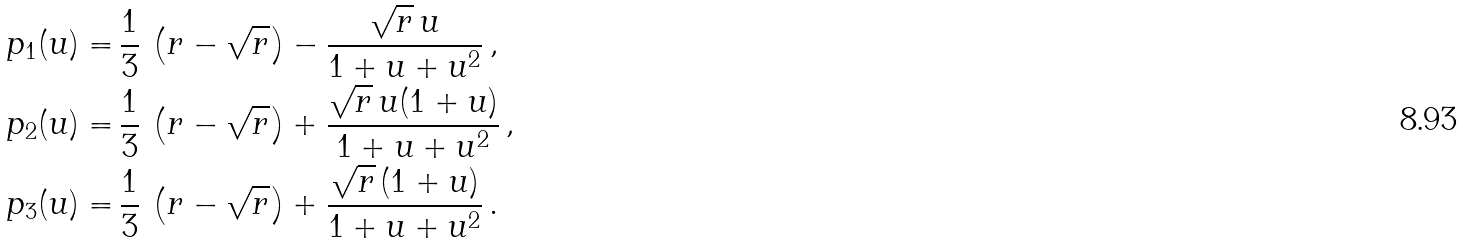Convert formula to latex. <formula><loc_0><loc_0><loc_500><loc_500>p _ { 1 } ( u ) = & \, \frac { 1 } { 3 } \, \left ( r - \sqrt { r } \right ) - \frac { \sqrt { r } \, u } { 1 + u + u ^ { 2 } } \, , \\ p _ { 2 } ( u ) = & \, \frac { 1 } { 3 } \, \left ( r - \sqrt { r } \right ) + \frac { \sqrt { r } \, u ( 1 + u ) } { 1 + u + u ^ { 2 } } \, , \\ p _ { 3 } ( u ) = & \, \frac { 1 } { 3 } \, \left ( r - \sqrt { r } \right ) + \frac { \sqrt { r } \, ( 1 + u ) } { 1 + u + u ^ { 2 } } \, .</formula> 